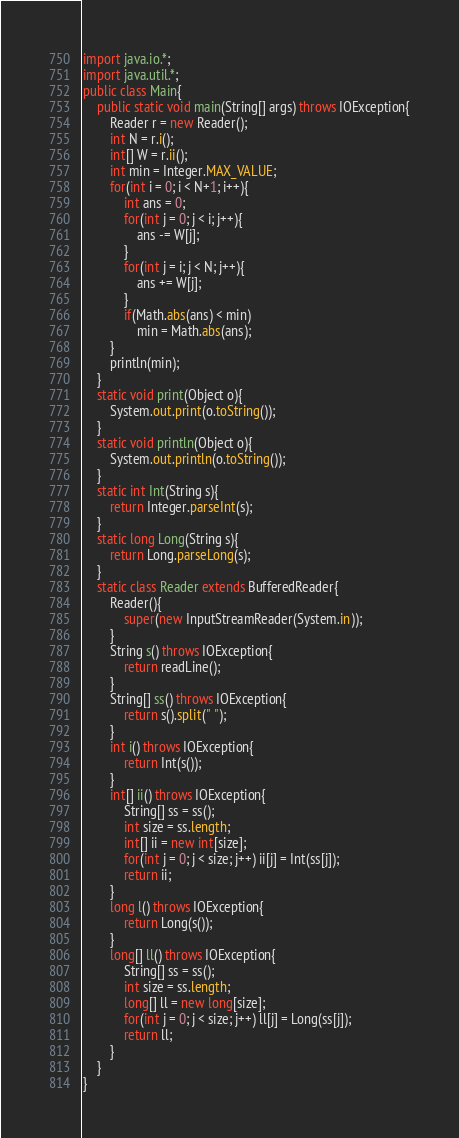<code> <loc_0><loc_0><loc_500><loc_500><_Java_>import java.io.*;
import java.util.*;
public class Main{
    public static void main(String[] args) throws IOException{
        Reader r = new Reader();        
        int N = r.i();
        int[] W = r.ii();   
        int min = Integer.MAX_VALUE;
        for(int i = 0; i < N+1; i++){
            int ans = 0;
            for(int j = 0; j < i; j++){
                ans -= W[j];
            }
            for(int j = i; j < N; j++){
                ans += W[j];
            }
            if(Math.abs(ans) < min)
                min = Math.abs(ans);
        }
        println(min);
    }
    static void print(Object o){
        System.out.print(o.toString());
    }
    static void println(Object o){
        System.out.println(o.toString());
    }
    static int Int(String s){
        return Integer.parseInt(s);
    }
    static long Long(String s){
        return Long.parseLong(s);
    }
    static class Reader extends BufferedReader{
        Reader(){
            super(new InputStreamReader(System.in));
        }
        String s() throws IOException{
            return readLine();
        }
        String[] ss() throws IOException{
            return s().split(" ");
        }
        int i() throws IOException{
            return Int(s());
        }
        int[] ii() throws IOException{
            String[] ss = ss();
            int size = ss.length;
            int[] ii = new int[size];
            for(int j = 0; j < size; j++) ii[j] = Int(ss[j]);
            return ii;
        }
        long l() throws IOException{
            return Long(s());
        }
        long[] ll() throws IOException{
            String[] ss = ss();
            int size = ss.length;
            long[] ll = new long[size];
            for(int j = 0; j < size; j++) ll[j] = Long(ss[j]);            
            return ll;
        }
    }
}</code> 